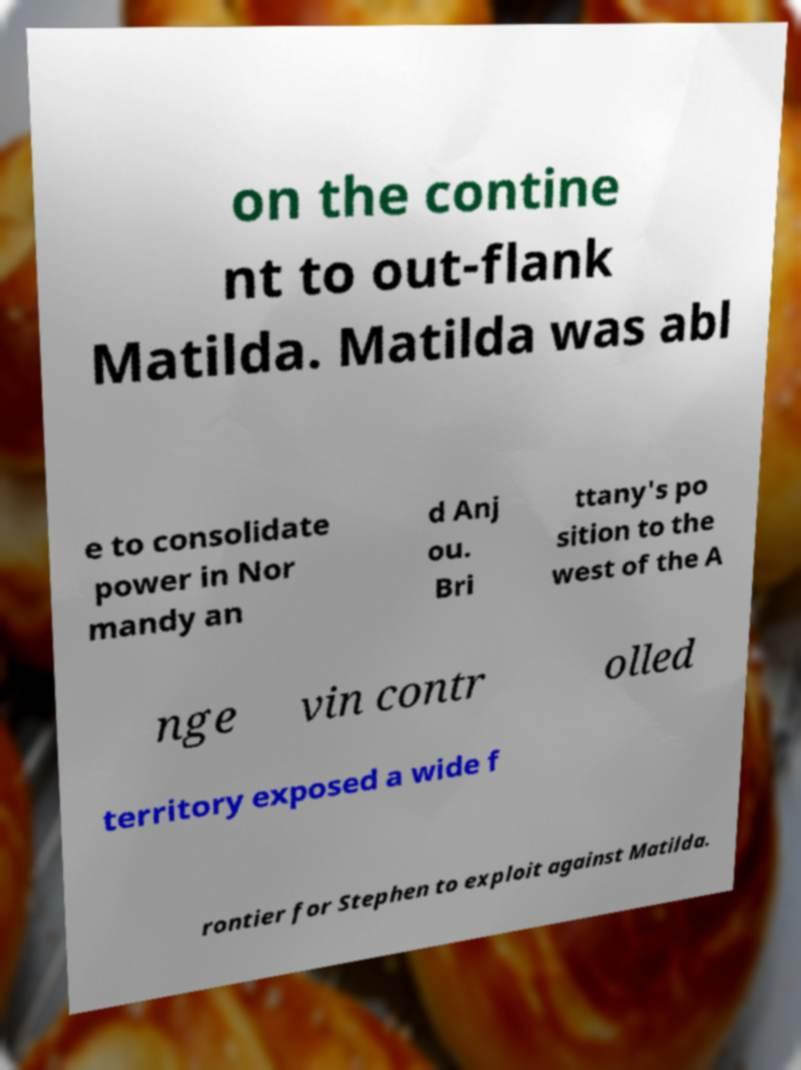I need the written content from this picture converted into text. Can you do that? on the contine nt to out-flank Matilda. Matilda was abl e to consolidate power in Nor mandy an d Anj ou. Bri ttany's po sition to the west of the A nge vin contr olled territory exposed a wide f rontier for Stephen to exploit against Matilda. 